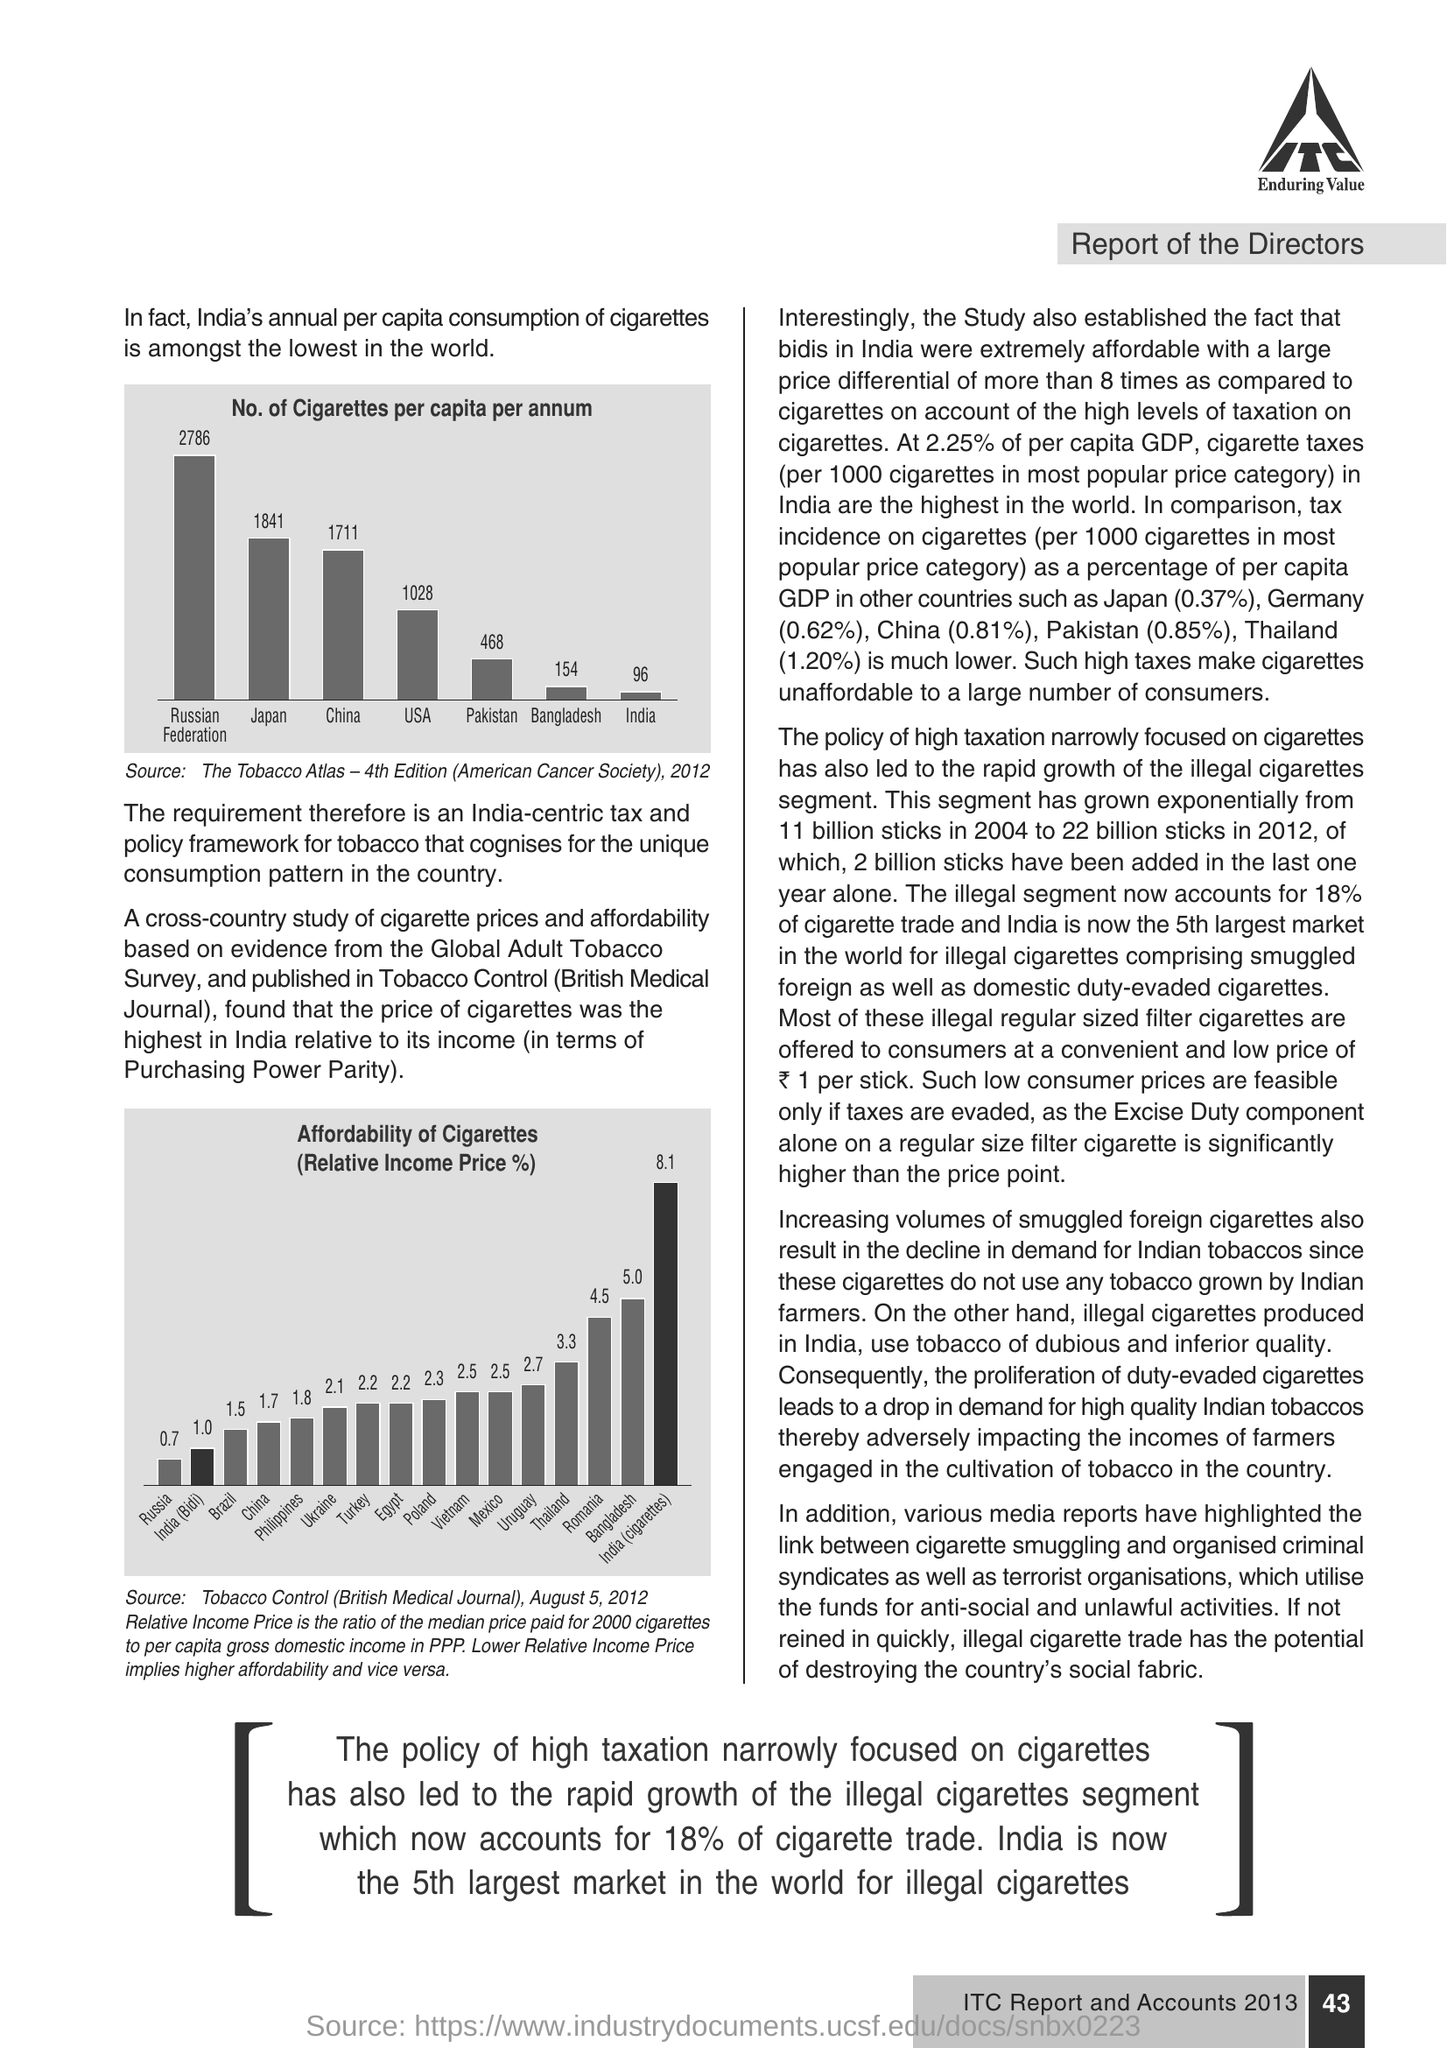Outline some significant characteristics in this image. In Pakistan, the percentage of GDP is 0.85%. 